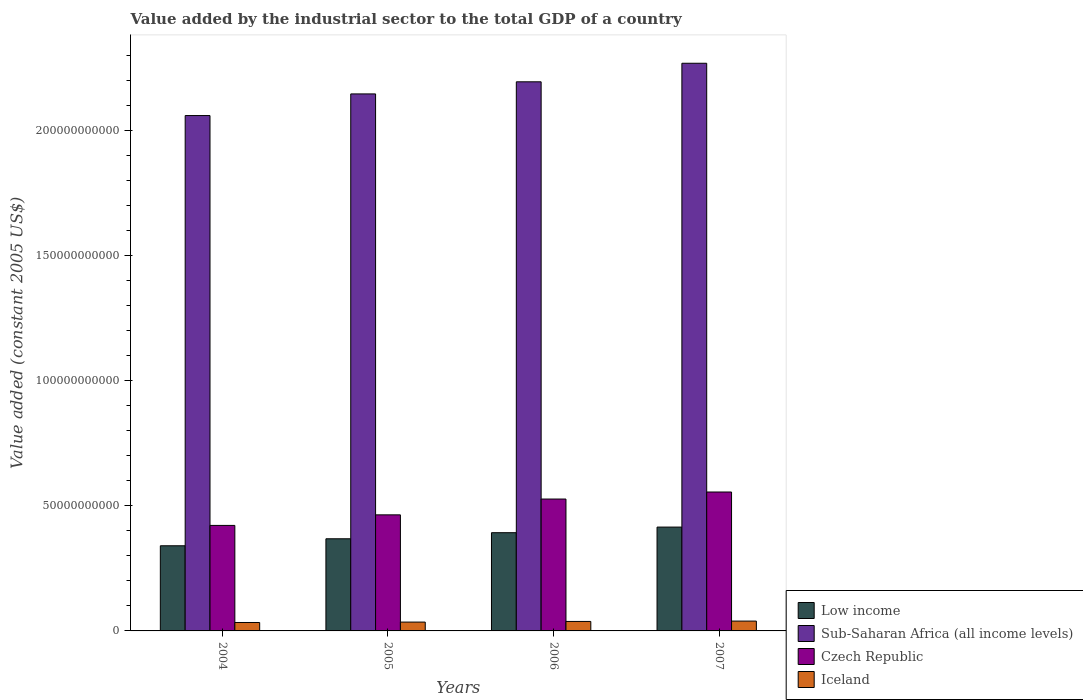How many different coloured bars are there?
Ensure brevity in your answer.  4. Are the number of bars per tick equal to the number of legend labels?
Give a very brief answer. Yes. Are the number of bars on each tick of the X-axis equal?
Your response must be concise. Yes. What is the label of the 1st group of bars from the left?
Make the answer very short. 2004. In how many cases, is the number of bars for a given year not equal to the number of legend labels?
Give a very brief answer. 0. What is the value added by the industrial sector in Iceland in 2007?
Your answer should be very brief. 3.93e+09. Across all years, what is the maximum value added by the industrial sector in Sub-Saharan Africa (all income levels)?
Keep it short and to the point. 2.27e+11. Across all years, what is the minimum value added by the industrial sector in Czech Republic?
Make the answer very short. 4.22e+1. What is the total value added by the industrial sector in Iceland in the graph?
Your response must be concise. 1.46e+1. What is the difference between the value added by the industrial sector in Czech Republic in 2004 and that in 2005?
Offer a terse response. -4.22e+09. What is the difference between the value added by the industrial sector in Czech Republic in 2005 and the value added by the industrial sector in Low income in 2006?
Ensure brevity in your answer.  7.14e+09. What is the average value added by the industrial sector in Low income per year?
Provide a short and direct response. 3.79e+1. In the year 2005, what is the difference between the value added by the industrial sector in Czech Republic and value added by the industrial sector in Sub-Saharan Africa (all income levels)?
Give a very brief answer. -1.68e+11. What is the ratio of the value added by the industrial sector in Czech Republic in 2004 to that in 2006?
Make the answer very short. 0.8. Is the value added by the industrial sector in Iceland in 2004 less than that in 2007?
Give a very brief answer. Yes. Is the difference between the value added by the industrial sector in Czech Republic in 2004 and 2007 greater than the difference between the value added by the industrial sector in Sub-Saharan Africa (all income levels) in 2004 and 2007?
Offer a terse response. Yes. What is the difference between the highest and the second highest value added by the industrial sector in Czech Republic?
Keep it short and to the point. 2.81e+09. What is the difference between the highest and the lowest value added by the industrial sector in Czech Republic?
Your response must be concise. 1.34e+1. Is it the case that in every year, the sum of the value added by the industrial sector in Low income and value added by the industrial sector in Czech Republic is greater than the sum of value added by the industrial sector in Sub-Saharan Africa (all income levels) and value added by the industrial sector in Iceland?
Make the answer very short. No. What does the 2nd bar from the left in 2004 represents?
Your response must be concise. Sub-Saharan Africa (all income levels). What does the 3rd bar from the right in 2004 represents?
Provide a short and direct response. Sub-Saharan Africa (all income levels). How many bars are there?
Ensure brevity in your answer.  16. How many years are there in the graph?
Your response must be concise. 4. What is the difference between two consecutive major ticks on the Y-axis?
Give a very brief answer. 5.00e+1. Are the values on the major ticks of Y-axis written in scientific E-notation?
Give a very brief answer. No. Does the graph contain grids?
Offer a very short reply. No. Where does the legend appear in the graph?
Your answer should be compact. Bottom right. How many legend labels are there?
Your response must be concise. 4. How are the legend labels stacked?
Give a very brief answer. Vertical. What is the title of the graph?
Give a very brief answer. Value added by the industrial sector to the total GDP of a country. Does "Vietnam" appear as one of the legend labels in the graph?
Keep it short and to the point. No. What is the label or title of the Y-axis?
Give a very brief answer. Value added (constant 2005 US$). What is the Value added (constant 2005 US$) of Low income in 2004?
Keep it short and to the point. 3.41e+1. What is the Value added (constant 2005 US$) in Sub-Saharan Africa (all income levels) in 2004?
Offer a very short reply. 2.06e+11. What is the Value added (constant 2005 US$) in Czech Republic in 2004?
Keep it short and to the point. 4.22e+1. What is the Value added (constant 2005 US$) of Iceland in 2004?
Your response must be concise. 3.37e+09. What is the Value added (constant 2005 US$) in Low income in 2005?
Keep it short and to the point. 3.69e+1. What is the Value added (constant 2005 US$) in Sub-Saharan Africa (all income levels) in 2005?
Offer a terse response. 2.15e+11. What is the Value added (constant 2005 US$) in Czech Republic in 2005?
Your response must be concise. 4.64e+1. What is the Value added (constant 2005 US$) in Iceland in 2005?
Ensure brevity in your answer.  3.53e+09. What is the Value added (constant 2005 US$) in Low income in 2006?
Give a very brief answer. 3.93e+1. What is the Value added (constant 2005 US$) in Sub-Saharan Africa (all income levels) in 2006?
Ensure brevity in your answer.  2.20e+11. What is the Value added (constant 2005 US$) in Czech Republic in 2006?
Offer a terse response. 5.28e+1. What is the Value added (constant 2005 US$) of Iceland in 2006?
Provide a short and direct response. 3.79e+09. What is the Value added (constant 2005 US$) of Low income in 2007?
Your response must be concise. 4.15e+1. What is the Value added (constant 2005 US$) in Sub-Saharan Africa (all income levels) in 2007?
Keep it short and to the point. 2.27e+11. What is the Value added (constant 2005 US$) in Czech Republic in 2007?
Offer a terse response. 5.56e+1. What is the Value added (constant 2005 US$) of Iceland in 2007?
Provide a short and direct response. 3.93e+09. Across all years, what is the maximum Value added (constant 2005 US$) of Low income?
Offer a very short reply. 4.15e+1. Across all years, what is the maximum Value added (constant 2005 US$) in Sub-Saharan Africa (all income levels)?
Your answer should be very brief. 2.27e+11. Across all years, what is the maximum Value added (constant 2005 US$) in Czech Republic?
Your answer should be compact. 5.56e+1. Across all years, what is the maximum Value added (constant 2005 US$) of Iceland?
Your response must be concise. 3.93e+09. Across all years, what is the minimum Value added (constant 2005 US$) in Low income?
Make the answer very short. 3.41e+1. Across all years, what is the minimum Value added (constant 2005 US$) in Sub-Saharan Africa (all income levels)?
Make the answer very short. 2.06e+11. Across all years, what is the minimum Value added (constant 2005 US$) of Czech Republic?
Your response must be concise. 4.22e+1. Across all years, what is the minimum Value added (constant 2005 US$) in Iceland?
Give a very brief answer. 3.37e+09. What is the total Value added (constant 2005 US$) of Low income in the graph?
Your response must be concise. 1.52e+11. What is the total Value added (constant 2005 US$) of Sub-Saharan Africa (all income levels) in the graph?
Make the answer very short. 8.68e+11. What is the total Value added (constant 2005 US$) in Czech Republic in the graph?
Your response must be concise. 1.97e+11. What is the total Value added (constant 2005 US$) in Iceland in the graph?
Keep it short and to the point. 1.46e+1. What is the difference between the Value added (constant 2005 US$) in Low income in 2004 and that in 2005?
Make the answer very short. -2.80e+09. What is the difference between the Value added (constant 2005 US$) in Sub-Saharan Africa (all income levels) in 2004 and that in 2005?
Offer a very short reply. -8.65e+09. What is the difference between the Value added (constant 2005 US$) of Czech Republic in 2004 and that in 2005?
Offer a very short reply. -4.22e+09. What is the difference between the Value added (constant 2005 US$) of Iceland in 2004 and that in 2005?
Provide a succinct answer. -1.65e+08. What is the difference between the Value added (constant 2005 US$) in Low income in 2004 and that in 2006?
Ensure brevity in your answer.  -5.23e+09. What is the difference between the Value added (constant 2005 US$) of Sub-Saharan Africa (all income levels) in 2004 and that in 2006?
Make the answer very short. -1.35e+1. What is the difference between the Value added (constant 2005 US$) of Czech Republic in 2004 and that in 2006?
Provide a succinct answer. -1.05e+1. What is the difference between the Value added (constant 2005 US$) of Iceland in 2004 and that in 2006?
Your answer should be compact. -4.20e+08. What is the difference between the Value added (constant 2005 US$) in Low income in 2004 and that in 2007?
Your response must be concise. -7.47e+09. What is the difference between the Value added (constant 2005 US$) in Sub-Saharan Africa (all income levels) in 2004 and that in 2007?
Give a very brief answer. -2.09e+1. What is the difference between the Value added (constant 2005 US$) of Czech Republic in 2004 and that in 2007?
Keep it short and to the point. -1.34e+1. What is the difference between the Value added (constant 2005 US$) in Iceland in 2004 and that in 2007?
Offer a very short reply. -5.63e+08. What is the difference between the Value added (constant 2005 US$) in Low income in 2005 and that in 2006?
Offer a terse response. -2.43e+09. What is the difference between the Value added (constant 2005 US$) in Sub-Saharan Africa (all income levels) in 2005 and that in 2006?
Provide a short and direct response. -4.84e+09. What is the difference between the Value added (constant 2005 US$) of Czech Republic in 2005 and that in 2006?
Make the answer very short. -6.32e+09. What is the difference between the Value added (constant 2005 US$) of Iceland in 2005 and that in 2006?
Provide a short and direct response. -2.55e+08. What is the difference between the Value added (constant 2005 US$) of Low income in 2005 and that in 2007?
Ensure brevity in your answer.  -4.67e+09. What is the difference between the Value added (constant 2005 US$) in Sub-Saharan Africa (all income levels) in 2005 and that in 2007?
Provide a succinct answer. -1.23e+1. What is the difference between the Value added (constant 2005 US$) in Czech Republic in 2005 and that in 2007?
Your answer should be compact. -9.13e+09. What is the difference between the Value added (constant 2005 US$) of Iceland in 2005 and that in 2007?
Give a very brief answer. -3.98e+08. What is the difference between the Value added (constant 2005 US$) in Low income in 2006 and that in 2007?
Ensure brevity in your answer.  -2.24e+09. What is the difference between the Value added (constant 2005 US$) in Sub-Saharan Africa (all income levels) in 2006 and that in 2007?
Your answer should be very brief. -7.42e+09. What is the difference between the Value added (constant 2005 US$) of Czech Republic in 2006 and that in 2007?
Make the answer very short. -2.81e+09. What is the difference between the Value added (constant 2005 US$) of Iceland in 2006 and that in 2007?
Your answer should be very brief. -1.43e+08. What is the difference between the Value added (constant 2005 US$) of Low income in 2004 and the Value added (constant 2005 US$) of Sub-Saharan Africa (all income levels) in 2005?
Your response must be concise. -1.81e+11. What is the difference between the Value added (constant 2005 US$) in Low income in 2004 and the Value added (constant 2005 US$) in Czech Republic in 2005?
Offer a very short reply. -1.24e+1. What is the difference between the Value added (constant 2005 US$) in Low income in 2004 and the Value added (constant 2005 US$) in Iceland in 2005?
Keep it short and to the point. 3.05e+1. What is the difference between the Value added (constant 2005 US$) in Sub-Saharan Africa (all income levels) in 2004 and the Value added (constant 2005 US$) in Czech Republic in 2005?
Provide a short and direct response. 1.60e+11. What is the difference between the Value added (constant 2005 US$) in Sub-Saharan Africa (all income levels) in 2004 and the Value added (constant 2005 US$) in Iceland in 2005?
Your answer should be compact. 2.03e+11. What is the difference between the Value added (constant 2005 US$) in Czech Republic in 2004 and the Value added (constant 2005 US$) in Iceland in 2005?
Give a very brief answer. 3.87e+1. What is the difference between the Value added (constant 2005 US$) in Low income in 2004 and the Value added (constant 2005 US$) in Sub-Saharan Africa (all income levels) in 2006?
Make the answer very short. -1.86e+11. What is the difference between the Value added (constant 2005 US$) in Low income in 2004 and the Value added (constant 2005 US$) in Czech Republic in 2006?
Keep it short and to the point. -1.87e+1. What is the difference between the Value added (constant 2005 US$) of Low income in 2004 and the Value added (constant 2005 US$) of Iceland in 2006?
Provide a short and direct response. 3.03e+1. What is the difference between the Value added (constant 2005 US$) of Sub-Saharan Africa (all income levels) in 2004 and the Value added (constant 2005 US$) of Czech Republic in 2006?
Give a very brief answer. 1.53e+11. What is the difference between the Value added (constant 2005 US$) of Sub-Saharan Africa (all income levels) in 2004 and the Value added (constant 2005 US$) of Iceland in 2006?
Your response must be concise. 2.02e+11. What is the difference between the Value added (constant 2005 US$) in Czech Republic in 2004 and the Value added (constant 2005 US$) in Iceland in 2006?
Your answer should be compact. 3.84e+1. What is the difference between the Value added (constant 2005 US$) of Low income in 2004 and the Value added (constant 2005 US$) of Sub-Saharan Africa (all income levels) in 2007?
Offer a very short reply. -1.93e+11. What is the difference between the Value added (constant 2005 US$) in Low income in 2004 and the Value added (constant 2005 US$) in Czech Republic in 2007?
Ensure brevity in your answer.  -2.15e+1. What is the difference between the Value added (constant 2005 US$) of Low income in 2004 and the Value added (constant 2005 US$) of Iceland in 2007?
Make the answer very short. 3.01e+1. What is the difference between the Value added (constant 2005 US$) in Sub-Saharan Africa (all income levels) in 2004 and the Value added (constant 2005 US$) in Czech Republic in 2007?
Your answer should be very brief. 1.51e+11. What is the difference between the Value added (constant 2005 US$) in Sub-Saharan Africa (all income levels) in 2004 and the Value added (constant 2005 US$) in Iceland in 2007?
Your response must be concise. 2.02e+11. What is the difference between the Value added (constant 2005 US$) of Czech Republic in 2004 and the Value added (constant 2005 US$) of Iceland in 2007?
Your answer should be compact. 3.83e+1. What is the difference between the Value added (constant 2005 US$) of Low income in 2005 and the Value added (constant 2005 US$) of Sub-Saharan Africa (all income levels) in 2006?
Offer a very short reply. -1.83e+11. What is the difference between the Value added (constant 2005 US$) of Low income in 2005 and the Value added (constant 2005 US$) of Czech Republic in 2006?
Ensure brevity in your answer.  -1.59e+1. What is the difference between the Value added (constant 2005 US$) in Low income in 2005 and the Value added (constant 2005 US$) in Iceland in 2006?
Make the answer very short. 3.31e+1. What is the difference between the Value added (constant 2005 US$) of Sub-Saharan Africa (all income levels) in 2005 and the Value added (constant 2005 US$) of Czech Republic in 2006?
Ensure brevity in your answer.  1.62e+11. What is the difference between the Value added (constant 2005 US$) in Sub-Saharan Africa (all income levels) in 2005 and the Value added (constant 2005 US$) in Iceland in 2006?
Make the answer very short. 2.11e+11. What is the difference between the Value added (constant 2005 US$) in Czech Republic in 2005 and the Value added (constant 2005 US$) in Iceland in 2006?
Give a very brief answer. 4.26e+1. What is the difference between the Value added (constant 2005 US$) of Low income in 2005 and the Value added (constant 2005 US$) of Sub-Saharan Africa (all income levels) in 2007?
Your answer should be very brief. -1.90e+11. What is the difference between the Value added (constant 2005 US$) in Low income in 2005 and the Value added (constant 2005 US$) in Czech Republic in 2007?
Your answer should be compact. -1.87e+1. What is the difference between the Value added (constant 2005 US$) in Low income in 2005 and the Value added (constant 2005 US$) in Iceland in 2007?
Offer a very short reply. 3.29e+1. What is the difference between the Value added (constant 2005 US$) in Sub-Saharan Africa (all income levels) in 2005 and the Value added (constant 2005 US$) in Czech Republic in 2007?
Ensure brevity in your answer.  1.59e+11. What is the difference between the Value added (constant 2005 US$) of Sub-Saharan Africa (all income levels) in 2005 and the Value added (constant 2005 US$) of Iceland in 2007?
Your answer should be compact. 2.11e+11. What is the difference between the Value added (constant 2005 US$) in Czech Republic in 2005 and the Value added (constant 2005 US$) in Iceland in 2007?
Your answer should be compact. 4.25e+1. What is the difference between the Value added (constant 2005 US$) of Low income in 2006 and the Value added (constant 2005 US$) of Sub-Saharan Africa (all income levels) in 2007?
Offer a very short reply. -1.88e+11. What is the difference between the Value added (constant 2005 US$) in Low income in 2006 and the Value added (constant 2005 US$) in Czech Republic in 2007?
Provide a short and direct response. -1.63e+1. What is the difference between the Value added (constant 2005 US$) in Low income in 2006 and the Value added (constant 2005 US$) in Iceland in 2007?
Your answer should be very brief. 3.54e+1. What is the difference between the Value added (constant 2005 US$) in Sub-Saharan Africa (all income levels) in 2006 and the Value added (constant 2005 US$) in Czech Republic in 2007?
Your answer should be compact. 1.64e+11. What is the difference between the Value added (constant 2005 US$) of Sub-Saharan Africa (all income levels) in 2006 and the Value added (constant 2005 US$) of Iceland in 2007?
Give a very brief answer. 2.16e+11. What is the difference between the Value added (constant 2005 US$) of Czech Republic in 2006 and the Value added (constant 2005 US$) of Iceland in 2007?
Ensure brevity in your answer.  4.88e+1. What is the average Value added (constant 2005 US$) in Low income per year?
Give a very brief answer. 3.79e+1. What is the average Value added (constant 2005 US$) of Sub-Saharan Africa (all income levels) per year?
Ensure brevity in your answer.  2.17e+11. What is the average Value added (constant 2005 US$) of Czech Republic per year?
Your answer should be very brief. 4.92e+1. What is the average Value added (constant 2005 US$) in Iceland per year?
Provide a succinct answer. 3.66e+09. In the year 2004, what is the difference between the Value added (constant 2005 US$) in Low income and Value added (constant 2005 US$) in Sub-Saharan Africa (all income levels)?
Offer a terse response. -1.72e+11. In the year 2004, what is the difference between the Value added (constant 2005 US$) in Low income and Value added (constant 2005 US$) in Czech Republic?
Offer a terse response. -8.14e+09. In the year 2004, what is the difference between the Value added (constant 2005 US$) in Low income and Value added (constant 2005 US$) in Iceland?
Offer a very short reply. 3.07e+1. In the year 2004, what is the difference between the Value added (constant 2005 US$) in Sub-Saharan Africa (all income levels) and Value added (constant 2005 US$) in Czech Republic?
Provide a succinct answer. 1.64e+11. In the year 2004, what is the difference between the Value added (constant 2005 US$) of Sub-Saharan Africa (all income levels) and Value added (constant 2005 US$) of Iceland?
Your answer should be very brief. 2.03e+11. In the year 2004, what is the difference between the Value added (constant 2005 US$) of Czech Republic and Value added (constant 2005 US$) of Iceland?
Provide a succinct answer. 3.88e+1. In the year 2005, what is the difference between the Value added (constant 2005 US$) in Low income and Value added (constant 2005 US$) in Sub-Saharan Africa (all income levels)?
Keep it short and to the point. -1.78e+11. In the year 2005, what is the difference between the Value added (constant 2005 US$) of Low income and Value added (constant 2005 US$) of Czech Republic?
Your answer should be compact. -9.57e+09. In the year 2005, what is the difference between the Value added (constant 2005 US$) in Low income and Value added (constant 2005 US$) in Iceland?
Offer a terse response. 3.33e+1. In the year 2005, what is the difference between the Value added (constant 2005 US$) in Sub-Saharan Africa (all income levels) and Value added (constant 2005 US$) in Czech Republic?
Offer a terse response. 1.68e+11. In the year 2005, what is the difference between the Value added (constant 2005 US$) in Sub-Saharan Africa (all income levels) and Value added (constant 2005 US$) in Iceland?
Your answer should be very brief. 2.11e+11. In the year 2005, what is the difference between the Value added (constant 2005 US$) in Czech Republic and Value added (constant 2005 US$) in Iceland?
Offer a terse response. 4.29e+1. In the year 2006, what is the difference between the Value added (constant 2005 US$) of Low income and Value added (constant 2005 US$) of Sub-Saharan Africa (all income levels)?
Your answer should be compact. -1.80e+11. In the year 2006, what is the difference between the Value added (constant 2005 US$) of Low income and Value added (constant 2005 US$) of Czech Republic?
Your answer should be very brief. -1.35e+1. In the year 2006, what is the difference between the Value added (constant 2005 US$) of Low income and Value added (constant 2005 US$) of Iceland?
Your response must be concise. 3.55e+1. In the year 2006, what is the difference between the Value added (constant 2005 US$) in Sub-Saharan Africa (all income levels) and Value added (constant 2005 US$) in Czech Republic?
Ensure brevity in your answer.  1.67e+11. In the year 2006, what is the difference between the Value added (constant 2005 US$) in Sub-Saharan Africa (all income levels) and Value added (constant 2005 US$) in Iceland?
Offer a very short reply. 2.16e+11. In the year 2006, what is the difference between the Value added (constant 2005 US$) of Czech Republic and Value added (constant 2005 US$) of Iceland?
Provide a succinct answer. 4.90e+1. In the year 2007, what is the difference between the Value added (constant 2005 US$) in Low income and Value added (constant 2005 US$) in Sub-Saharan Africa (all income levels)?
Your response must be concise. -1.86e+11. In the year 2007, what is the difference between the Value added (constant 2005 US$) in Low income and Value added (constant 2005 US$) in Czech Republic?
Offer a terse response. -1.40e+1. In the year 2007, what is the difference between the Value added (constant 2005 US$) in Low income and Value added (constant 2005 US$) in Iceland?
Your answer should be compact. 3.76e+1. In the year 2007, what is the difference between the Value added (constant 2005 US$) of Sub-Saharan Africa (all income levels) and Value added (constant 2005 US$) of Czech Republic?
Make the answer very short. 1.71e+11. In the year 2007, what is the difference between the Value added (constant 2005 US$) in Sub-Saharan Africa (all income levels) and Value added (constant 2005 US$) in Iceland?
Keep it short and to the point. 2.23e+11. In the year 2007, what is the difference between the Value added (constant 2005 US$) of Czech Republic and Value added (constant 2005 US$) of Iceland?
Make the answer very short. 5.16e+1. What is the ratio of the Value added (constant 2005 US$) of Low income in 2004 to that in 2005?
Ensure brevity in your answer.  0.92. What is the ratio of the Value added (constant 2005 US$) of Sub-Saharan Africa (all income levels) in 2004 to that in 2005?
Give a very brief answer. 0.96. What is the ratio of the Value added (constant 2005 US$) of Czech Republic in 2004 to that in 2005?
Provide a short and direct response. 0.91. What is the ratio of the Value added (constant 2005 US$) in Iceland in 2004 to that in 2005?
Ensure brevity in your answer.  0.95. What is the ratio of the Value added (constant 2005 US$) in Low income in 2004 to that in 2006?
Your answer should be very brief. 0.87. What is the ratio of the Value added (constant 2005 US$) in Sub-Saharan Africa (all income levels) in 2004 to that in 2006?
Keep it short and to the point. 0.94. What is the ratio of the Value added (constant 2005 US$) of Czech Republic in 2004 to that in 2006?
Ensure brevity in your answer.  0.8. What is the ratio of the Value added (constant 2005 US$) in Iceland in 2004 to that in 2006?
Your answer should be very brief. 0.89. What is the ratio of the Value added (constant 2005 US$) in Low income in 2004 to that in 2007?
Provide a short and direct response. 0.82. What is the ratio of the Value added (constant 2005 US$) of Sub-Saharan Africa (all income levels) in 2004 to that in 2007?
Your answer should be very brief. 0.91. What is the ratio of the Value added (constant 2005 US$) of Czech Republic in 2004 to that in 2007?
Make the answer very short. 0.76. What is the ratio of the Value added (constant 2005 US$) in Iceland in 2004 to that in 2007?
Ensure brevity in your answer.  0.86. What is the ratio of the Value added (constant 2005 US$) in Low income in 2005 to that in 2006?
Your answer should be very brief. 0.94. What is the ratio of the Value added (constant 2005 US$) in Sub-Saharan Africa (all income levels) in 2005 to that in 2006?
Your answer should be very brief. 0.98. What is the ratio of the Value added (constant 2005 US$) of Czech Republic in 2005 to that in 2006?
Ensure brevity in your answer.  0.88. What is the ratio of the Value added (constant 2005 US$) in Iceland in 2005 to that in 2006?
Make the answer very short. 0.93. What is the ratio of the Value added (constant 2005 US$) of Low income in 2005 to that in 2007?
Keep it short and to the point. 0.89. What is the ratio of the Value added (constant 2005 US$) in Sub-Saharan Africa (all income levels) in 2005 to that in 2007?
Make the answer very short. 0.95. What is the ratio of the Value added (constant 2005 US$) of Czech Republic in 2005 to that in 2007?
Keep it short and to the point. 0.84. What is the ratio of the Value added (constant 2005 US$) in Iceland in 2005 to that in 2007?
Offer a terse response. 0.9. What is the ratio of the Value added (constant 2005 US$) in Low income in 2006 to that in 2007?
Your answer should be very brief. 0.95. What is the ratio of the Value added (constant 2005 US$) in Sub-Saharan Africa (all income levels) in 2006 to that in 2007?
Your response must be concise. 0.97. What is the ratio of the Value added (constant 2005 US$) in Czech Republic in 2006 to that in 2007?
Your response must be concise. 0.95. What is the ratio of the Value added (constant 2005 US$) of Iceland in 2006 to that in 2007?
Your answer should be very brief. 0.96. What is the difference between the highest and the second highest Value added (constant 2005 US$) of Low income?
Give a very brief answer. 2.24e+09. What is the difference between the highest and the second highest Value added (constant 2005 US$) of Sub-Saharan Africa (all income levels)?
Your response must be concise. 7.42e+09. What is the difference between the highest and the second highest Value added (constant 2005 US$) in Czech Republic?
Offer a terse response. 2.81e+09. What is the difference between the highest and the second highest Value added (constant 2005 US$) in Iceland?
Your answer should be compact. 1.43e+08. What is the difference between the highest and the lowest Value added (constant 2005 US$) of Low income?
Ensure brevity in your answer.  7.47e+09. What is the difference between the highest and the lowest Value added (constant 2005 US$) of Sub-Saharan Africa (all income levels)?
Keep it short and to the point. 2.09e+1. What is the difference between the highest and the lowest Value added (constant 2005 US$) of Czech Republic?
Keep it short and to the point. 1.34e+1. What is the difference between the highest and the lowest Value added (constant 2005 US$) in Iceland?
Provide a short and direct response. 5.63e+08. 